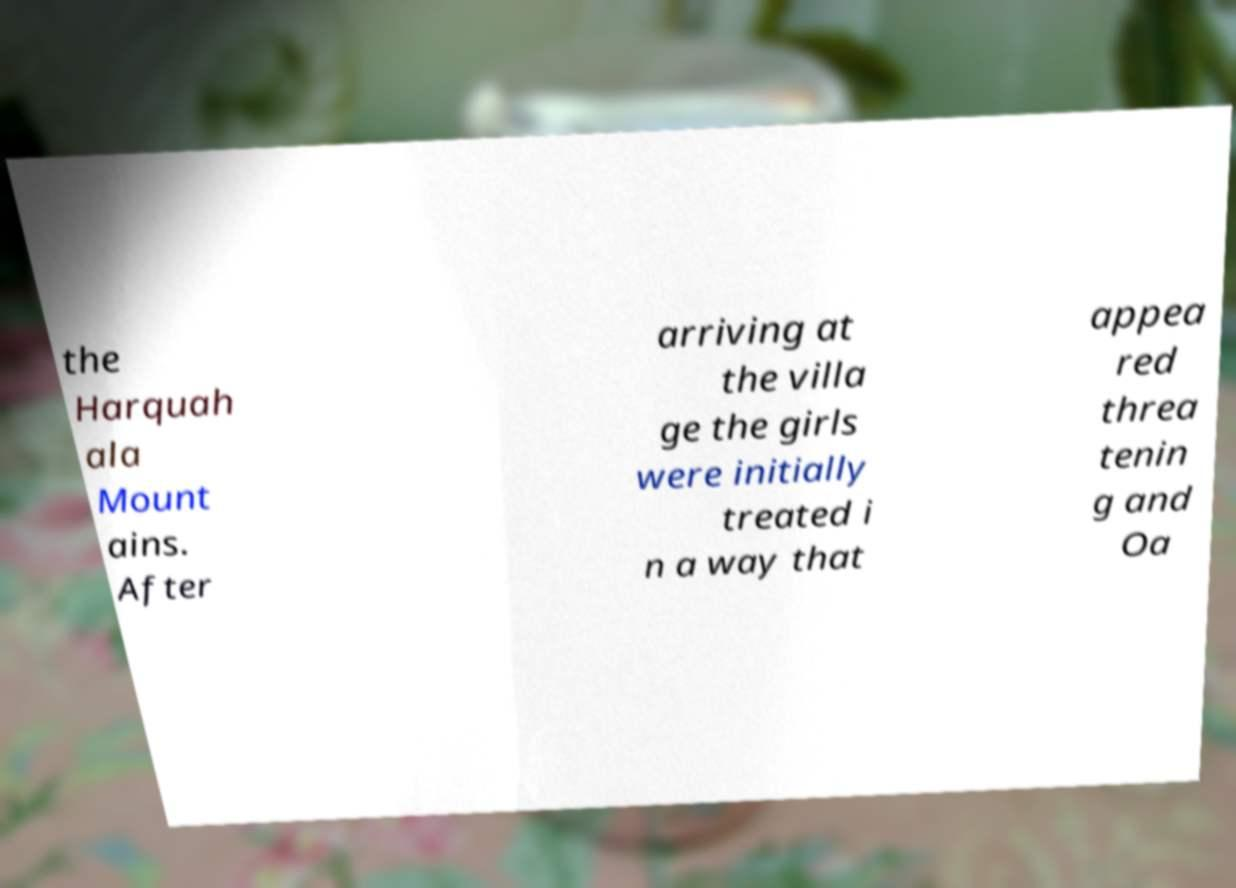For documentation purposes, I need the text within this image transcribed. Could you provide that? the Harquah ala Mount ains. After arriving at the villa ge the girls were initially treated i n a way that appea red threa tenin g and Oa 